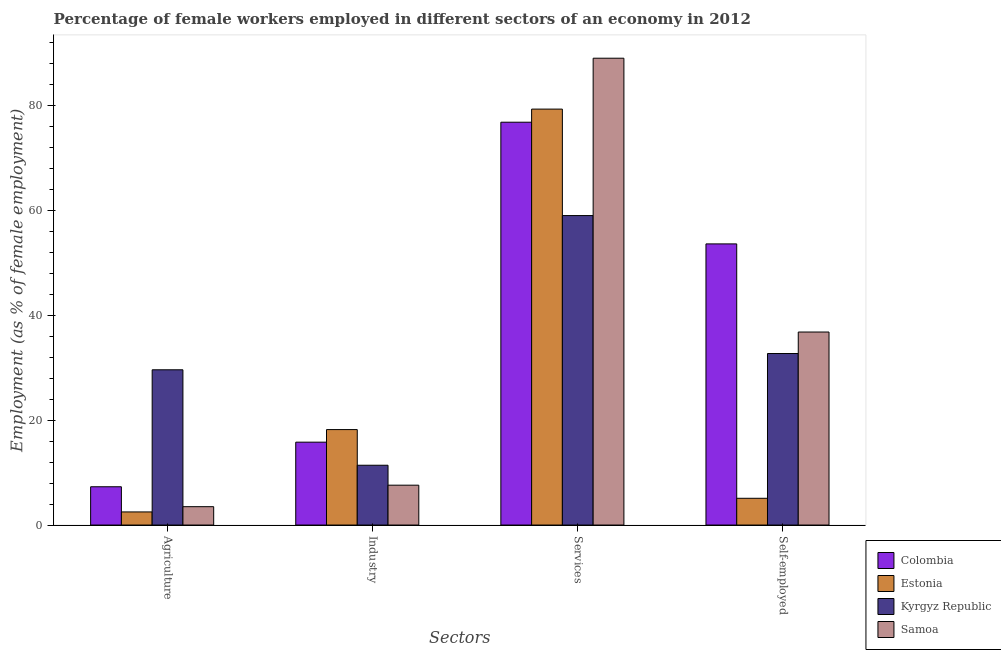How many different coloured bars are there?
Make the answer very short. 4. How many groups of bars are there?
Your answer should be compact. 4. Are the number of bars per tick equal to the number of legend labels?
Give a very brief answer. Yes. What is the label of the 4th group of bars from the left?
Offer a very short reply. Self-employed. What is the percentage of female workers in industry in Samoa?
Your answer should be compact. 7.6. Across all countries, what is the maximum percentage of self employed female workers?
Ensure brevity in your answer.  53.6. Across all countries, what is the minimum percentage of female workers in agriculture?
Keep it short and to the point. 2.5. In which country was the percentage of female workers in industry maximum?
Ensure brevity in your answer.  Estonia. In which country was the percentage of female workers in industry minimum?
Provide a short and direct response. Samoa. What is the total percentage of female workers in agriculture in the graph?
Make the answer very short. 42.9. What is the difference between the percentage of female workers in industry in Estonia and the percentage of female workers in agriculture in Colombia?
Your answer should be very brief. 10.9. What is the average percentage of female workers in services per country?
Make the answer very short. 76.03. What is the difference between the percentage of female workers in agriculture and percentage of self employed female workers in Kyrgyz Republic?
Make the answer very short. -3.1. In how many countries, is the percentage of female workers in agriculture greater than 12 %?
Ensure brevity in your answer.  1. What is the ratio of the percentage of female workers in industry in Estonia to that in Colombia?
Your answer should be compact. 1.15. Is the percentage of female workers in agriculture in Colombia less than that in Samoa?
Ensure brevity in your answer.  No. Is the difference between the percentage of self employed female workers in Estonia and Kyrgyz Republic greater than the difference between the percentage of female workers in industry in Estonia and Kyrgyz Republic?
Provide a succinct answer. No. What is the difference between the highest and the second highest percentage of female workers in services?
Offer a very short reply. 9.7. What is the difference between the highest and the lowest percentage of female workers in industry?
Offer a very short reply. 10.6. What does the 1st bar from the left in Services represents?
Keep it short and to the point. Colombia. What does the 3rd bar from the right in Self-employed represents?
Provide a short and direct response. Estonia. How many countries are there in the graph?
Provide a short and direct response. 4. What is the difference between two consecutive major ticks on the Y-axis?
Provide a succinct answer. 20. What is the title of the graph?
Give a very brief answer. Percentage of female workers employed in different sectors of an economy in 2012. Does "Mauritius" appear as one of the legend labels in the graph?
Your response must be concise. No. What is the label or title of the X-axis?
Ensure brevity in your answer.  Sectors. What is the label or title of the Y-axis?
Your answer should be very brief. Employment (as % of female employment). What is the Employment (as % of female employment) of Colombia in Agriculture?
Make the answer very short. 7.3. What is the Employment (as % of female employment) in Kyrgyz Republic in Agriculture?
Ensure brevity in your answer.  29.6. What is the Employment (as % of female employment) in Colombia in Industry?
Your answer should be compact. 15.8. What is the Employment (as % of female employment) in Estonia in Industry?
Provide a short and direct response. 18.2. What is the Employment (as % of female employment) in Kyrgyz Republic in Industry?
Provide a succinct answer. 11.4. What is the Employment (as % of female employment) in Samoa in Industry?
Give a very brief answer. 7.6. What is the Employment (as % of female employment) of Colombia in Services?
Provide a succinct answer. 76.8. What is the Employment (as % of female employment) in Estonia in Services?
Give a very brief answer. 79.3. What is the Employment (as % of female employment) of Kyrgyz Republic in Services?
Provide a short and direct response. 59. What is the Employment (as % of female employment) in Samoa in Services?
Your response must be concise. 89. What is the Employment (as % of female employment) in Colombia in Self-employed?
Your answer should be compact. 53.6. What is the Employment (as % of female employment) in Estonia in Self-employed?
Offer a terse response. 5.1. What is the Employment (as % of female employment) in Kyrgyz Republic in Self-employed?
Offer a terse response. 32.7. What is the Employment (as % of female employment) of Samoa in Self-employed?
Keep it short and to the point. 36.8. Across all Sectors, what is the maximum Employment (as % of female employment) in Colombia?
Provide a short and direct response. 76.8. Across all Sectors, what is the maximum Employment (as % of female employment) in Estonia?
Offer a terse response. 79.3. Across all Sectors, what is the maximum Employment (as % of female employment) in Kyrgyz Republic?
Give a very brief answer. 59. Across all Sectors, what is the maximum Employment (as % of female employment) in Samoa?
Offer a very short reply. 89. Across all Sectors, what is the minimum Employment (as % of female employment) in Colombia?
Give a very brief answer. 7.3. Across all Sectors, what is the minimum Employment (as % of female employment) in Estonia?
Your answer should be compact. 2.5. Across all Sectors, what is the minimum Employment (as % of female employment) in Kyrgyz Republic?
Give a very brief answer. 11.4. Across all Sectors, what is the minimum Employment (as % of female employment) of Samoa?
Make the answer very short. 3.5. What is the total Employment (as % of female employment) in Colombia in the graph?
Ensure brevity in your answer.  153.5. What is the total Employment (as % of female employment) in Estonia in the graph?
Your answer should be compact. 105.1. What is the total Employment (as % of female employment) in Kyrgyz Republic in the graph?
Offer a very short reply. 132.7. What is the total Employment (as % of female employment) in Samoa in the graph?
Give a very brief answer. 136.9. What is the difference between the Employment (as % of female employment) in Estonia in Agriculture and that in Industry?
Your response must be concise. -15.7. What is the difference between the Employment (as % of female employment) of Colombia in Agriculture and that in Services?
Provide a succinct answer. -69.5. What is the difference between the Employment (as % of female employment) of Estonia in Agriculture and that in Services?
Your response must be concise. -76.8. What is the difference between the Employment (as % of female employment) of Kyrgyz Republic in Agriculture and that in Services?
Give a very brief answer. -29.4. What is the difference between the Employment (as % of female employment) in Samoa in Agriculture and that in Services?
Offer a terse response. -85.5. What is the difference between the Employment (as % of female employment) in Colombia in Agriculture and that in Self-employed?
Ensure brevity in your answer.  -46.3. What is the difference between the Employment (as % of female employment) in Kyrgyz Republic in Agriculture and that in Self-employed?
Your answer should be very brief. -3.1. What is the difference between the Employment (as % of female employment) in Samoa in Agriculture and that in Self-employed?
Your response must be concise. -33.3. What is the difference between the Employment (as % of female employment) of Colombia in Industry and that in Services?
Offer a terse response. -61. What is the difference between the Employment (as % of female employment) in Estonia in Industry and that in Services?
Your response must be concise. -61.1. What is the difference between the Employment (as % of female employment) in Kyrgyz Republic in Industry and that in Services?
Provide a succinct answer. -47.6. What is the difference between the Employment (as % of female employment) in Samoa in Industry and that in Services?
Provide a succinct answer. -81.4. What is the difference between the Employment (as % of female employment) of Colombia in Industry and that in Self-employed?
Your response must be concise. -37.8. What is the difference between the Employment (as % of female employment) of Kyrgyz Republic in Industry and that in Self-employed?
Ensure brevity in your answer.  -21.3. What is the difference between the Employment (as % of female employment) of Samoa in Industry and that in Self-employed?
Give a very brief answer. -29.2. What is the difference between the Employment (as % of female employment) in Colombia in Services and that in Self-employed?
Your answer should be compact. 23.2. What is the difference between the Employment (as % of female employment) in Estonia in Services and that in Self-employed?
Provide a succinct answer. 74.2. What is the difference between the Employment (as % of female employment) of Kyrgyz Republic in Services and that in Self-employed?
Provide a short and direct response. 26.3. What is the difference between the Employment (as % of female employment) in Samoa in Services and that in Self-employed?
Provide a succinct answer. 52.2. What is the difference between the Employment (as % of female employment) of Colombia in Agriculture and the Employment (as % of female employment) of Estonia in Industry?
Provide a short and direct response. -10.9. What is the difference between the Employment (as % of female employment) in Colombia in Agriculture and the Employment (as % of female employment) in Estonia in Services?
Offer a very short reply. -72. What is the difference between the Employment (as % of female employment) of Colombia in Agriculture and the Employment (as % of female employment) of Kyrgyz Republic in Services?
Your answer should be compact. -51.7. What is the difference between the Employment (as % of female employment) of Colombia in Agriculture and the Employment (as % of female employment) of Samoa in Services?
Offer a very short reply. -81.7. What is the difference between the Employment (as % of female employment) in Estonia in Agriculture and the Employment (as % of female employment) in Kyrgyz Republic in Services?
Keep it short and to the point. -56.5. What is the difference between the Employment (as % of female employment) in Estonia in Agriculture and the Employment (as % of female employment) in Samoa in Services?
Make the answer very short. -86.5. What is the difference between the Employment (as % of female employment) in Kyrgyz Republic in Agriculture and the Employment (as % of female employment) in Samoa in Services?
Provide a short and direct response. -59.4. What is the difference between the Employment (as % of female employment) of Colombia in Agriculture and the Employment (as % of female employment) of Estonia in Self-employed?
Offer a very short reply. 2.2. What is the difference between the Employment (as % of female employment) of Colombia in Agriculture and the Employment (as % of female employment) of Kyrgyz Republic in Self-employed?
Provide a succinct answer. -25.4. What is the difference between the Employment (as % of female employment) of Colombia in Agriculture and the Employment (as % of female employment) of Samoa in Self-employed?
Your response must be concise. -29.5. What is the difference between the Employment (as % of female employment) in Estonia in Agriculture and the Employment (as % of female employment) in Kyrgyz Republic in Self-employed?
Your answer should be compact. -30.2. What is the difference between the Employment (as % of female employment) of Estonia in Agriculture and the Employment (as % of female employment) of Samoa in Self-employed?
Your answer should be compact. -34.3. What is the difference between the Employment (as % of female employment) in Colombia in Industry and the Employment (as % of female employment) in Estonia in Services?
Give a very brief answer. -63.5. What is the difference between the Employment (as % of female employment) in Colombia in Industry and the Employment (as % of female employment) in Kyrgyz Republic in Services?
Your response must be concise. -43.2. What is the difference between the Employment (as % of female employment) of Colombia in Industry and the Employment (as % of female employment) of Samoa in Services?
Offer a very short reply. -73.2. What is the difference between the Employment (as % of female employment) in Estonia in Industry and the Employment (as % of female employment) in Kyrgyz Republic in Services?
Keep it short and to the point. -40.8. What is the difference between the Employment (as % of female employment) in Estonia in Industry and the Employment (as % of female employment) in Samoa in Services?
Ensure brevity in your answer.  -70.8. What is the difference between the Employment (as % of female employment) of Kyrgyz Republic in Industry and the Employment (as % of female employment) of Samoa in Services?
Keep it short and to the point. -77.6. What is the difference between the Employment (as % of female employment) of Colombia in Industry and the Employment (as % of female employment) of Kyrgyz Republic in Self-employed?
Your response must be concise. -16.9. What is the difference between the Employment (as % of female employment) of Estonia in Industry and the Employment (as % of female employment) of Samoa in Self-employed?
Offer a very short reply. -18.6. What is the difference between the Employment (as % of female employment) in Kyrgyz Republic in Industry and the Employment (as % of female employment) in Samoa in Self-employed?
Ensure brevity in your answer.  -25.4. What is the difference between the Employment (as % of female employment) in Colombia in Services and the Employment (as % of female employment) in Estonia in Self-employed?
Provide a succinct answer. 71.7. What is the difference between the Employment (as % of female employment) of Colombia in Services and the Employment (as % of female employment) of Kyrgyz Republic in Self-employed?
Your answer should be compact. 44.1. What is the difference between the Employment (as % of female employment) in Colombia in Services and the Employment (as % of female employment) in Samoa in Self-employed?
Offer a very short reply. 40. What is the difference between the Employment (as % of female employment) of Estonia in Services and the Employment (as % of female employment) of Kyrgyz Republic in Self-employed?
Your answer should be very brief. 46.6. What is the difference between the Employment (as % of female employment) in Estonia in Services and the Employment (as % of female employment) in Samoa in Self-employed?
Your answer should be compact. 42.5. What is the average Employment (as % of female employment) in Colombia per Sectors?
Give a very brief answer. 38.38. What is the average Employment (as % of female employment) of Estonia per Sectors?
Give a very brief answer. 26.27. What is the average Employment (as % of female employment) in Kyrgyz Republic per Sectors?
Your answer should be compact. 33.17. What is the average Employment (as % of female employment) in Samoa per Sectors?
Give a very brief answer. 34.23. What is the difference between the Employment (as % of female employment) in Colombia and Employment (as % of female employment) in Estonia in Agriculture?
Make the answer very short. 4.8. What is the difference between the Employment (as % of female employment) of Colombia and Employment (as % of female employment) of Kyrgyz Republic in Agriculture?
Your answer should be compact. -22.3. What is the difference between the Employment (as % of female employment) in Estonia and Employment (as % of female employment) in Kyrgyz Republic in Agriculture?
Ensure brevity in your answer.  -27.1. What is the difference between the Employment (as % of female employment) of Kyrgyz Republic and Employment (as % of female employment) of Samoa in Agriculture?
Your response must be concise. 26.1. What is the difference between the Employment (as % of female employment) in Colombia and Employment (as % of female employment) in Estonia in Industry?
Keep it short and to the point. -2.4. What is the difference between the Employment (as % of female employment) in Colombia and Employment (as % of female employment) in Samoa in Industry?
Your answer should be compact. 8.2. What is the difference between the Employment (as % of female employment) of Estonia and Employment (as % of female employment) of Kyrgyz Republic in Industry?
Your answer should be very brief. 6.8. What is the difference between the Employment (as % of female employment) in Colombia and Employment (as % of female employment) in Estonia in Services?
Provide a succinct answer. -2.5. What is the difference between the Employment (as % of female employment) in Colombia and Employment (as % of female employment) in Samoa in Services?
Provide a short and direct response. -12.2. What is the difference between the Employment (as % of female employment) in Estonia and Employment (as % of female employment) in Kyrgyz Republic in Services?
Ensure brevity in your answer.  20.3. What is the difference between the Employment (as % of female employment) of Estonia and Employment (as % of female employment) of Samoa in Services?
Ensure brevity in your answer.  -9.7. What is the difference between the Employment (as % of female employment) in Colombia and Employment (as % of female employment) in Estonia in Self-employed?
Provide a succinct answer. 48.5. What is the difference between the Employment (as % of female employment) in Colombia and Employment (as % of female employment) in Kyrgyz Republic in Self-employed?
Your answer should be compact. 20.9. What is the difference between the Employment (as % of female employment) of Colombia and Employment (as % of female employment) of Samoa in Self-employed?
Provide a short and direct response. 16.8. What is the difference between the Employment (as % of female employment) in Estonia and Employment (as % of female employment) in Kyrgyz Republic in Self-employed?
Your answer should be very brief. -27.6. What is the difference between the Employment (as % of female employment) of Estonia and Employment (as % of female employment) of Samoa in Self-employed?
Ensure brevity in your answer.  -31.7. What is the ratio of the Employment (as % of female employment) of Colombia in Agriculture to that in Industry?
Provide a succinct answer. 0.46. What is the ratio of the Employment (as % of female employment) of Estonia in Agriculture to that in Industry?
Make the answer very short. 0.14. What is the ratio of the Employment (as % of female employment) of Kyrgyz Republic in Agriculture to that in Industry?
Offer a very short reply. 2.6. What is the ratio of the Employment (as % of female employment) of Samoa in Agriculture to that in Industry?
Keep it short and to the point. 0.46. What is the ratio of the Employment (as % of female employment) in Colombia in Agriculture to that in Services?
Your answer should be very brief. 0.1. What is the ratio of the Employment (as % of female employment) in Estonia in Agriculture to that in Services?
Provide a short and direct response. 0.03. What is the ratio of the Employment (as % of female employment) of Kyrgyz Republic in Agriculture to that in Services?
Your answer should be compact. 0.5. What is the ratio of the Employment (as % of female employment) in Samoa in Agriculture to that in Services?
Offer a terse response. 0.04. What is the ratio of the Employment (as % of female employment) of Colombia in Agriculture to that in Self-employed?
Give a very brief answer. 0.14. What is the ratio of the Employment (as % of female employment) of Estonia in Agriculture to that in Self-employed?
Provide a short and direct response. 0.49. What is the ratio of the Employment (as % of female employment) of Kyrgyz Republic in Agriculture to that in Self-employed?
Your response must be concise. 0.91. What is the ratio of the Employment (as % of female employment) in Samoa in Agriculture to that in Self-employed?
Your response must be concise. 0.1. What is the ratio of the Employment (as % of female employment) of Colombia in Industry to that in Services?
Your answer should be very brief. 0.21. What is the ratio of the Employment (as % of female employment) in Estonia in Industry to that in Services?
Offer a very short reply. 0.23. What is the ratio of the Employment (as % of female employment) of Kyrgyz Republic in Industry to that in Services?
Provide a short and direct response. 0.19. What is the ratio of the Employment (as % of female employment) of Samoa in Industry to that in Services?
Provide a short and direct response. 0.09. What is the ratio of the Employment (as % of female employment) in Colombia in Industry to that in Self-employed?
Make the answer very short. 0.29. What is the ratio of the Employment (as % of female employment) of Estonia in Industry to that in Self-employed?
Keep it short and to the point. 3.57. What is the ratio of the Employment (as % of female employment) in Kyrgyz Republic in Industry to that in Self-employed?
Your answer should be compact. 0.35. What is the ratio of the Employment (as % of female employment) of Samoa in Industry to that in Self-employed?
Your answer should be very brief. 0.21. What is the ratio of the Employment (as % of female employment) in Colombia in Services to that in Self-employed?
Keep it short and to the point. 1.43. What is the ratio of the Employment (as % of female employment) in Estonia in Services to that in Self-employed?
Make the answer very short. 15.55. What is the ratio of the Employment (as % of female employment) of Kyrgyz Republic in Services to that in Self-employed?
Provide a succinct answer. 1.8. What is the ratio of the Employment (as % of female employment) of Samoa in Services to that in Self-employed?
Your response must be concise. 2.42. What is the difference between the highest and the second highest Employment (as % of female employment) in Colombia?
Offer a terse response. 23.2. What is the difference between the highest and the second highest Employment (as % of female employment) in Estonia?
Your response must be concise. 61.1. What is the difference between the highest and the second highest Employment (as % of female employment) in Kyrgyz Republic?
Keep it short and to the point. 26.3. What is the difference between the highest and the second highest Employment (as % of female employment) in Samoa?
Provide a succinct answer. 52.2. What is the difference between the highest and the lowest Employment (as % of female employment) of Colombia?
Offer a terse response. 69.5. What is the difference between the highest and the lowest Employment (as % of female employment) in Estonia?
Offer a terse response. 76.8. What is the difference between the highest and the lowest Employment (as % of female employment) in Kyrgyz Republic?
Make the answer very short. 47.6. What is the difference between the highest and the lowest Employment (as % of female employment) of Samoa?
Your response must be concise. 85.5. 